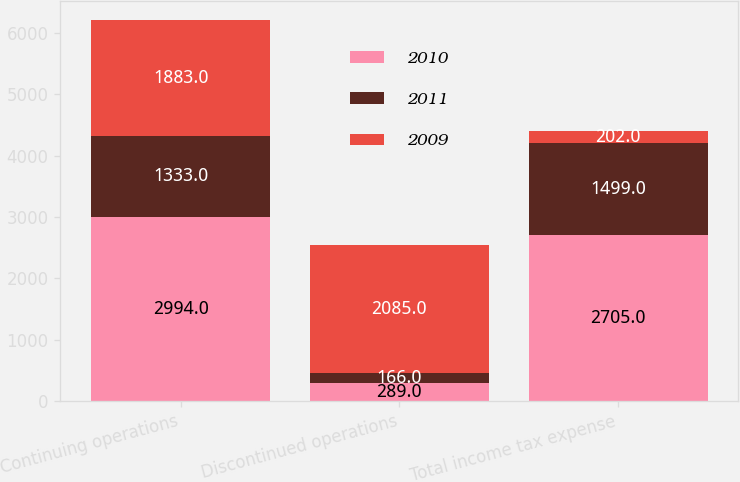Convert chart to OTSL. <chart><loc_0><loc_0><loc_500><loc_500><stacked_bar_chart><ecel><fcel>Continuing operations<fcel>Discontinued operations<fcel>Total income tax expense<nl><fcel>2010<fcel>2994<fcel>289<fcel>2705<nl><fcel>2011<fcel>1333<fcel>166<fcel>1499<nl><fcel>2009<fcel>1883<fcel>2085<fcel>202<nl></chart> 